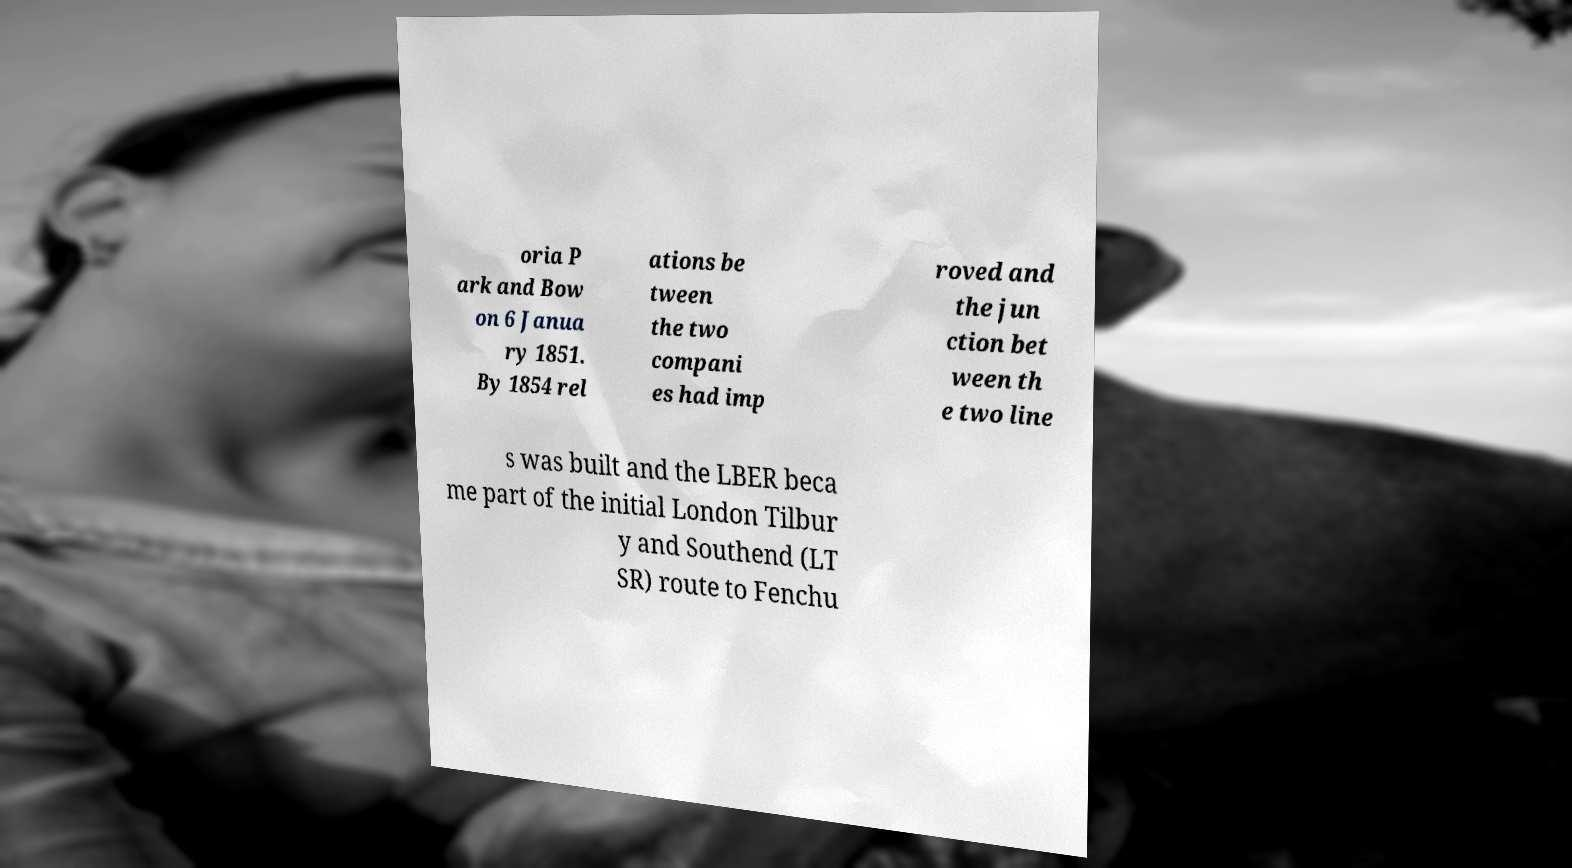For documentation purposes, I need the text within this image transcribed. Could you provide that? oria P ark and Bow on 6 Janua ry 1851. By 1854 rel ations be tween the two compani es had imp roved and the jun ction bet ween th e two line s was built and the LBER beca me part of the initial London Tilbur y and Southend (LT SR) route to Fenchu 